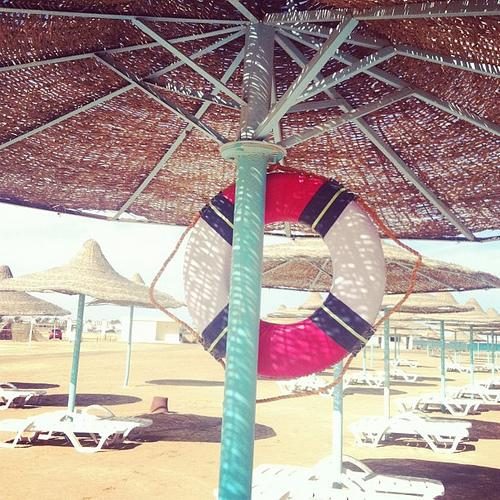Identify a color and an object associated with it in the image. The pole is associated with the color blue. What is the primary setting of the image? The primary setting of the image is a sandy beach. Briefly describe the weather conditions in the image. The weather in the image appears to be partly cloudy with blue sky. List all objects in the image associated with the beach setting. Beach umbrella on blue pole, sandy beach, lounge chairs, life saver on the pole, and umbrellas and beach chairs. Are there any vehicles present in the image? If yes, describe them. Yes, there is a red jeep and a red car in the background. Count the total number of lounge chairs in the image. There are a total of eleven lounge chairs in the image. Please mention one object on the beach and how it can be used. A lounge chair on the beach can be used for relaxing and sunbathing. What is the most noticeable object on a pole in the image? The most noticeable object on a pole is the life saver. 